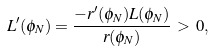<formula> <loc_0><loc_0><loc_500><loc_500>L ^ { \prime } ( \phi _ { N } ) = \frac { - r ^ { \prime } ( \phi _ { N } ) L ( \phi _ { N } ) } { r ( \phi _ { N } ) } \, > \, 0 ,</formula> 